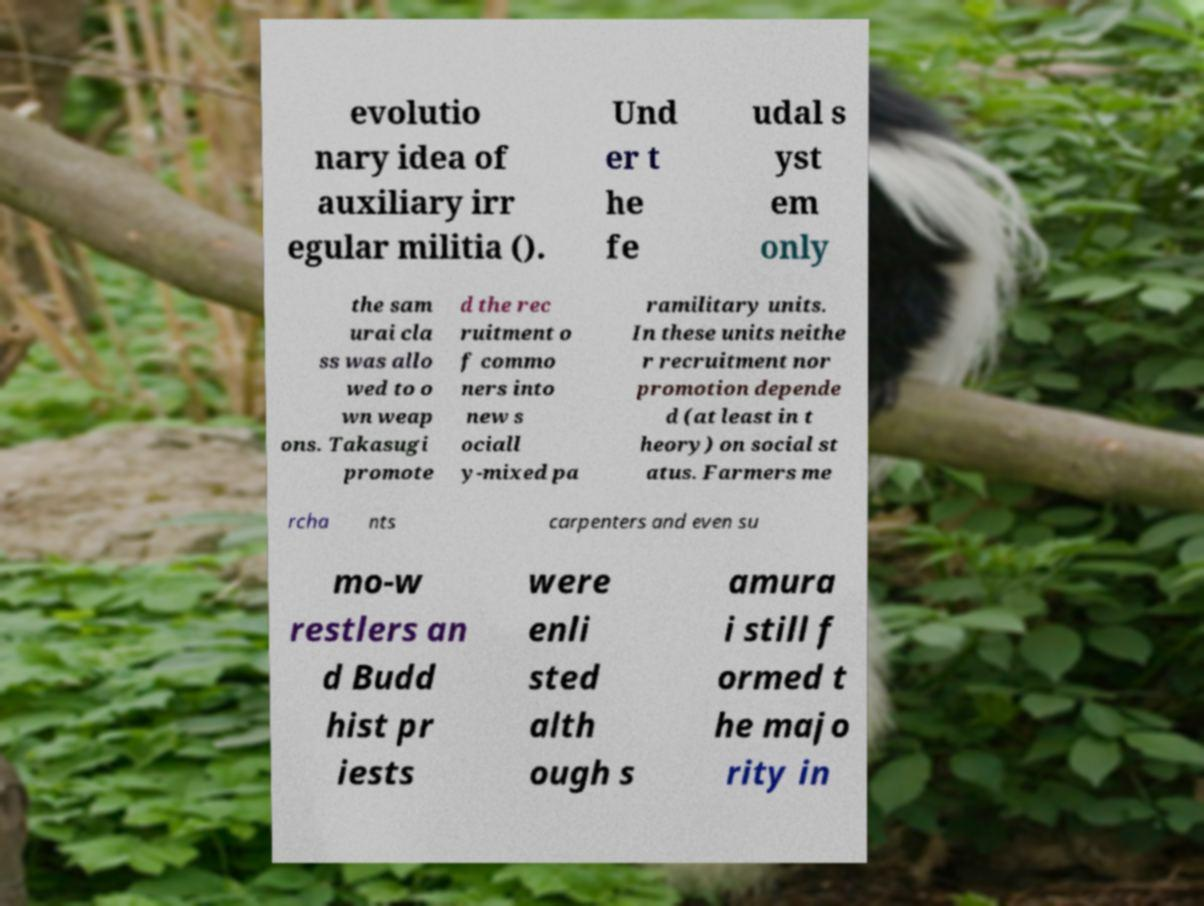Can you read and provide the text displayed in the image?This photo seems to have some interesting text. Can you extract and type it out for me? evolutio nary idea of auxiliary irr egular militia (). Und er t he fe udal s yst em only the sam urai cla ss was allo wed to o wn weap ons. Takasugi promote d the rec ruitment o f commo ners into new s ociall y-mixed pa ramilitary units. In these units neithe r recruitment nor promotion depende d (at least in t heory) on social st atus. Farmers me rcha nts carpenters and even su mo-w restlers an d Budd hist pr iests were enli sted alth ough s amura i still f ormed t he majo rity in 